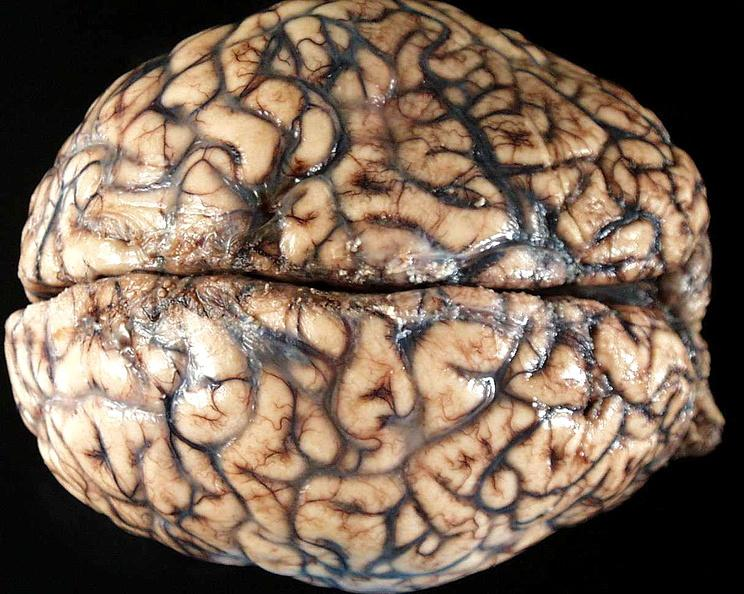does this image show brain, cryptococcal meningitis?
Answer the question using a single word or phrase. Yes 